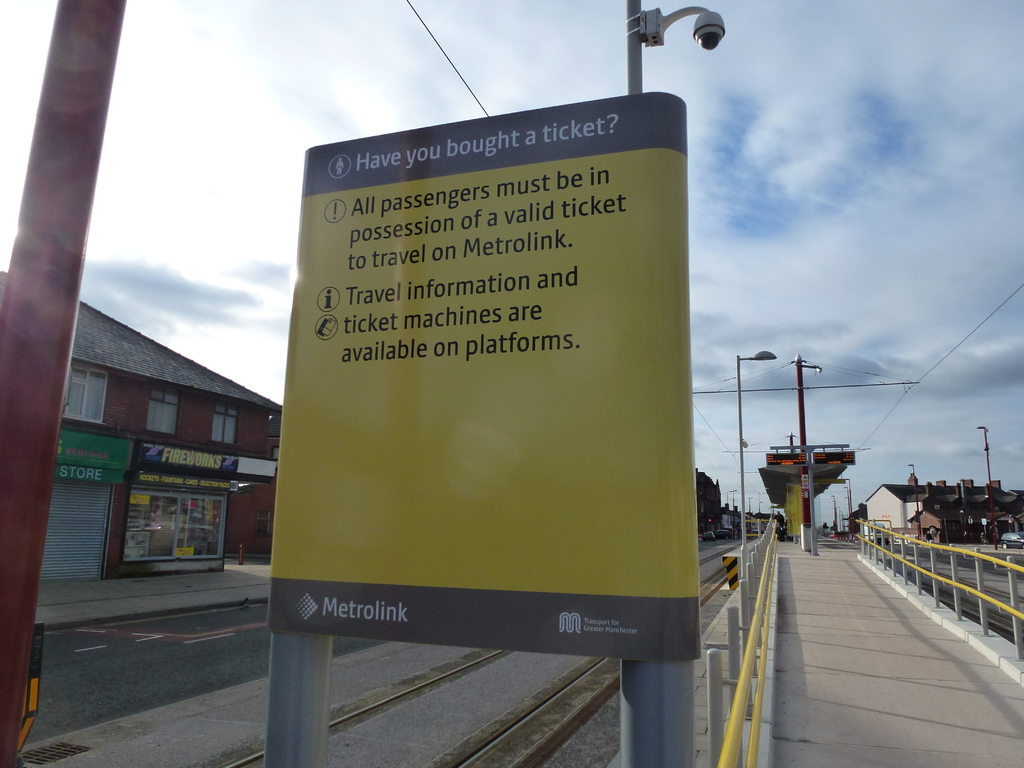What does the presence of the surveillance camera indicate about this location? The surveillance camera mounted on the top of the yellow sign underscores a focus on security and safety within the Metrolink station area. This installation is indicative of measures taken to ensure passenger safety, prevent crime, and monitor the flow of people and activities around this vital transit hub. It reflects an investment in maintaining a secure environment for commuters, which is essential in urban transit areas. 